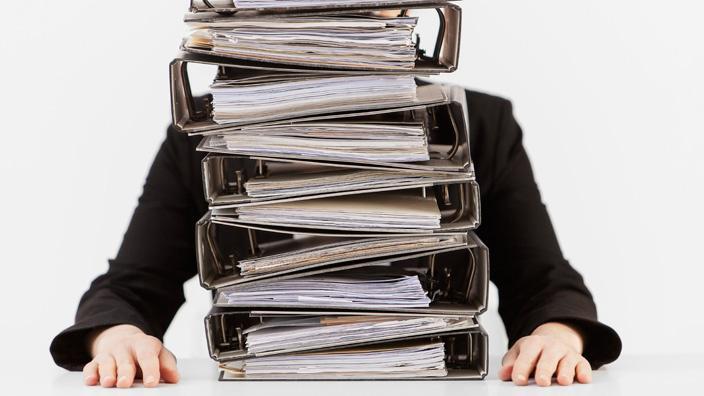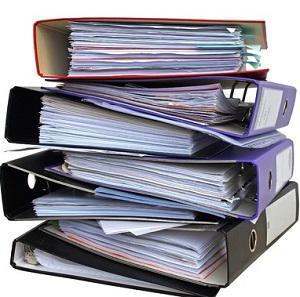The first image is the image on the left, the second image is the image on the right. Given the left and right images, does the statement "A person is sitting behind a stack of binders in one of the images." hold true? Answer yes or no. Yes. The first image is the image on the left, the second image is the image on the right. For the images displayed, is the sentence "The left image contains a person seated behind a stack of binders." factually correct? Answer yes or no. Yes. 